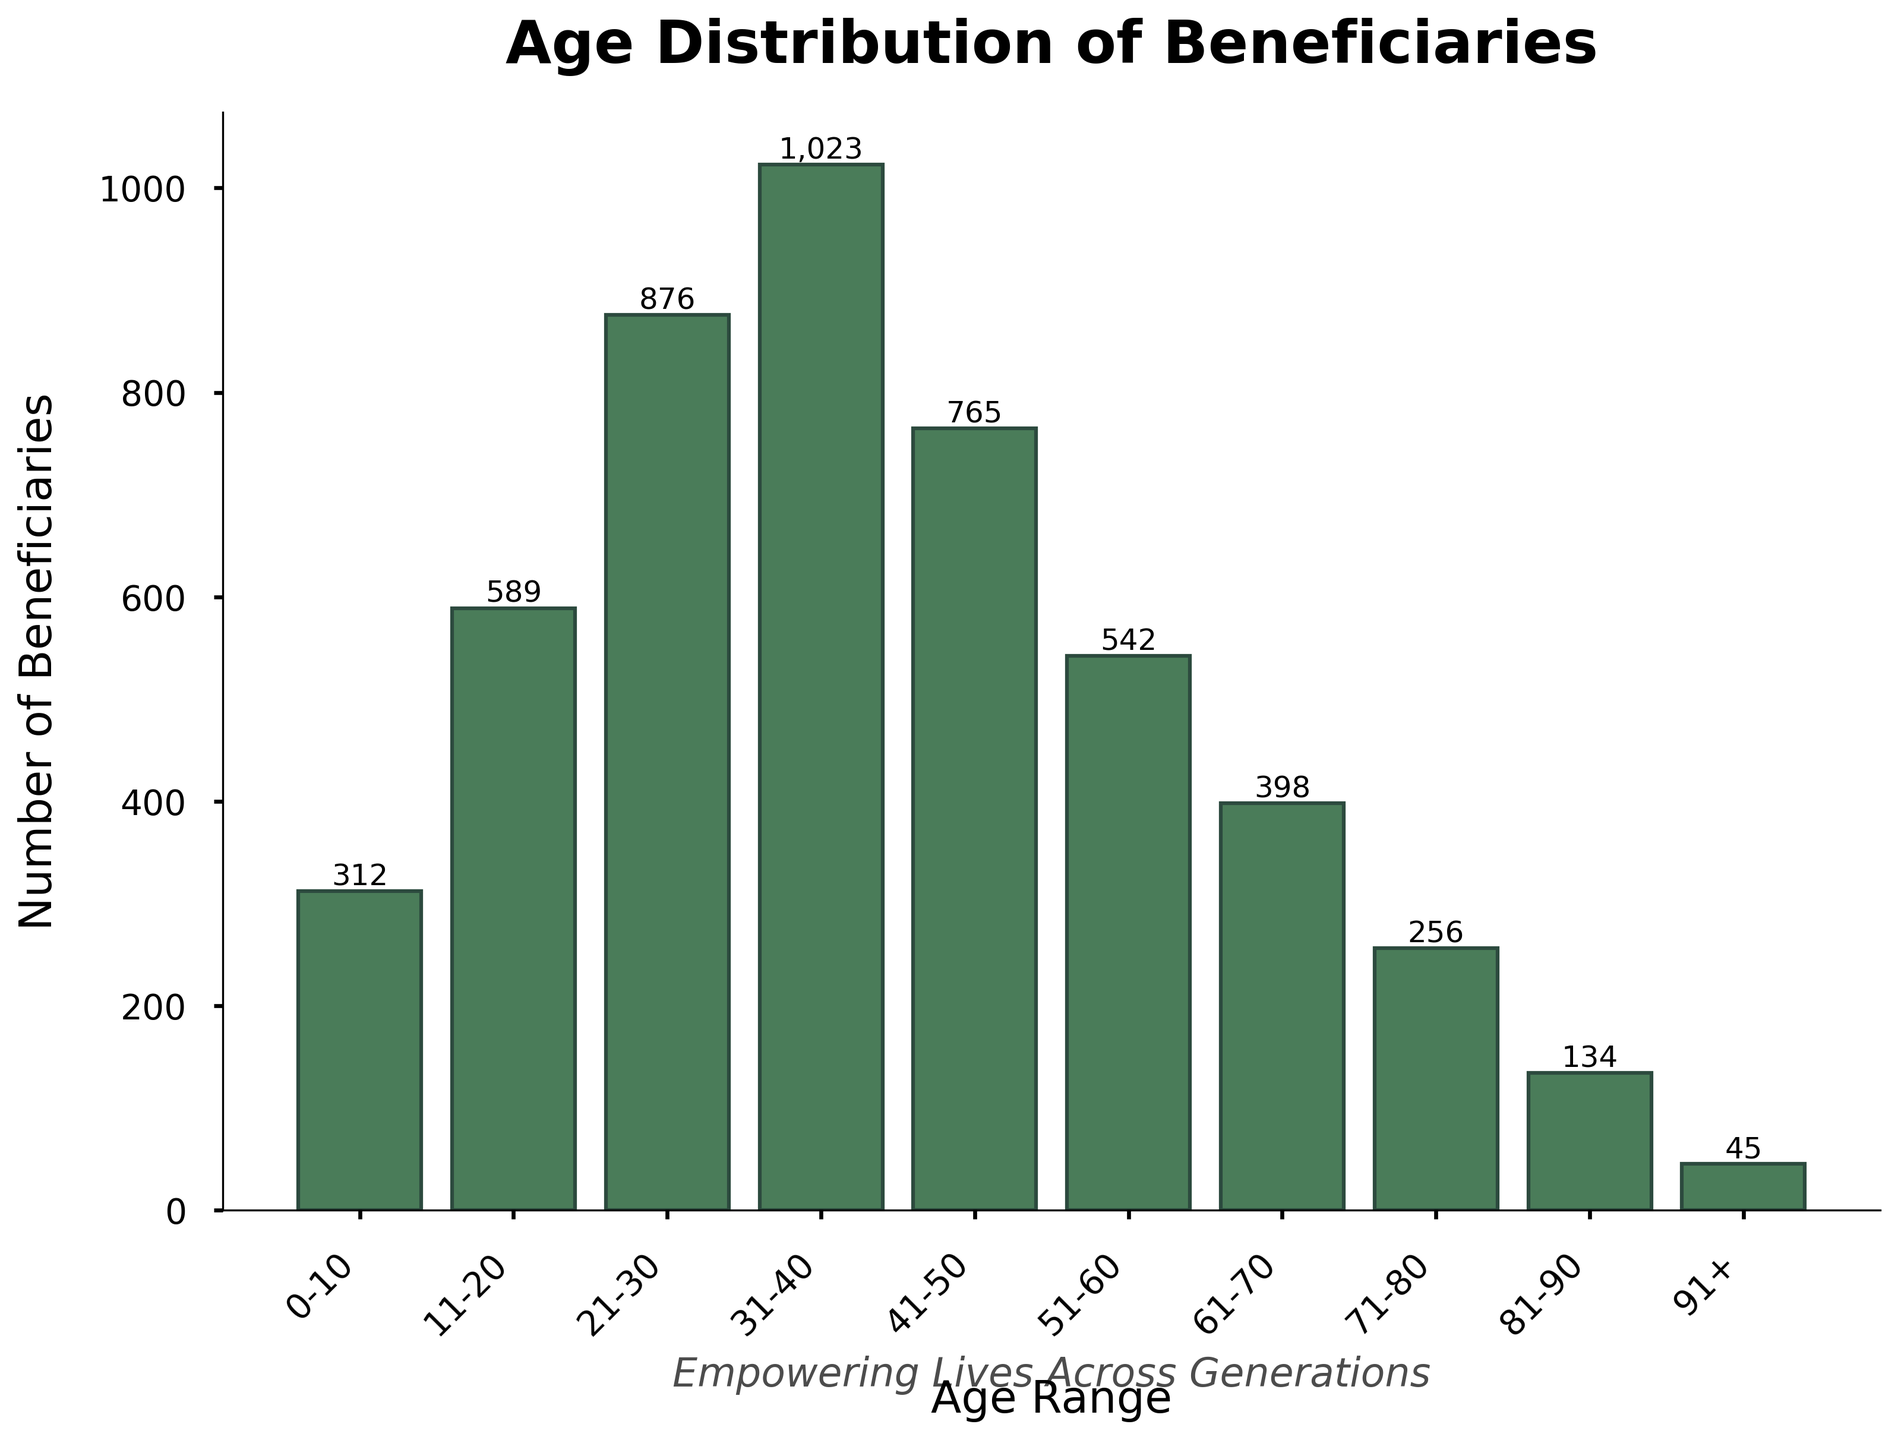What is the title of the figure? The title of the figure is written at the top and reads 'Age Distribution of Beneficiaries'.
Answer: Age Distribution of Beneficiaries Which age range has the highest number of beneficiaries? Look at the height of the bars in the histogram and identify the tallest one. The tallest bar corresponds to the '31-40' age range.
Answer: 31-40 How many beneficiaries are in the 11-20 and 21-30 age ranges combined? Add up the numbers from the '11-20' and '21-30' age ranges. 589 (11-20) + 876 (21-30) = 1465.
Answer: 1465 By how much does the number of beneficiaries in the 41-50 age range differ from those in the 31-40 age range? Subtract the number of beneficiaries in the '41-50' range from those in the '31-40' range. 1023 (31-40) - 765 (41-50) = 258.
Answer: 258 Which age range has the least number of beneficiaries? Identify the shortest bar in the histogram, which corresponds to the '91+' age range.
Answer: 91+ What is the total number of beneficiaries across all age ranges? Sum all the numbers from each age range. 312 + 589 + 876 + 1023 + 765 + 542 + 398 + 256 + 134 + 45 = 4940.
Answer: 4940 What is the average number of beneficiaries per age range? Calculate the total number of beneficiaries and divide by the number of age ranges. Total beneficiaries = 4940. Number of age ranges = 10. So, 4940 / 10 = 494.
Answer: 494 Is the number of beneficiaries in the '51-60' age range greater than those in the '41-50' age range? Compare the heights of bars for the '51-60' and '41-50' age ranges. 542 (51-60) is less than 765 (41-50).
Answer: No How does the number of beneficiaries in the '81-90' age range compare to that in the '71-80' age range? Compare the heights of the bars for these two age ranges. The '81-90' range has 134 beneficiaries whereas the '71-80' range has 256.
Answer: Less What is the difference in the number of beneficiaries between the youngest (0-10) and the oldest age (91+) ranges? Subtract the number of beneficiaries in the '91+' range from those in the '0-10' range. 312 (0-10) - 45 (91+) = 267.
Answer: 267 